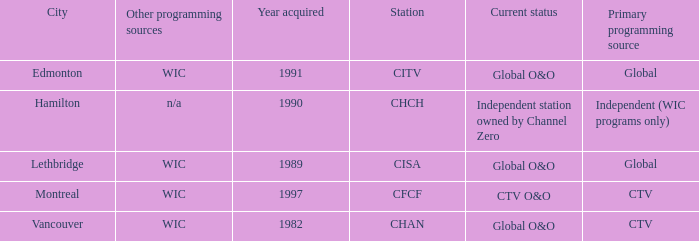Where is citv located Edmonton. 